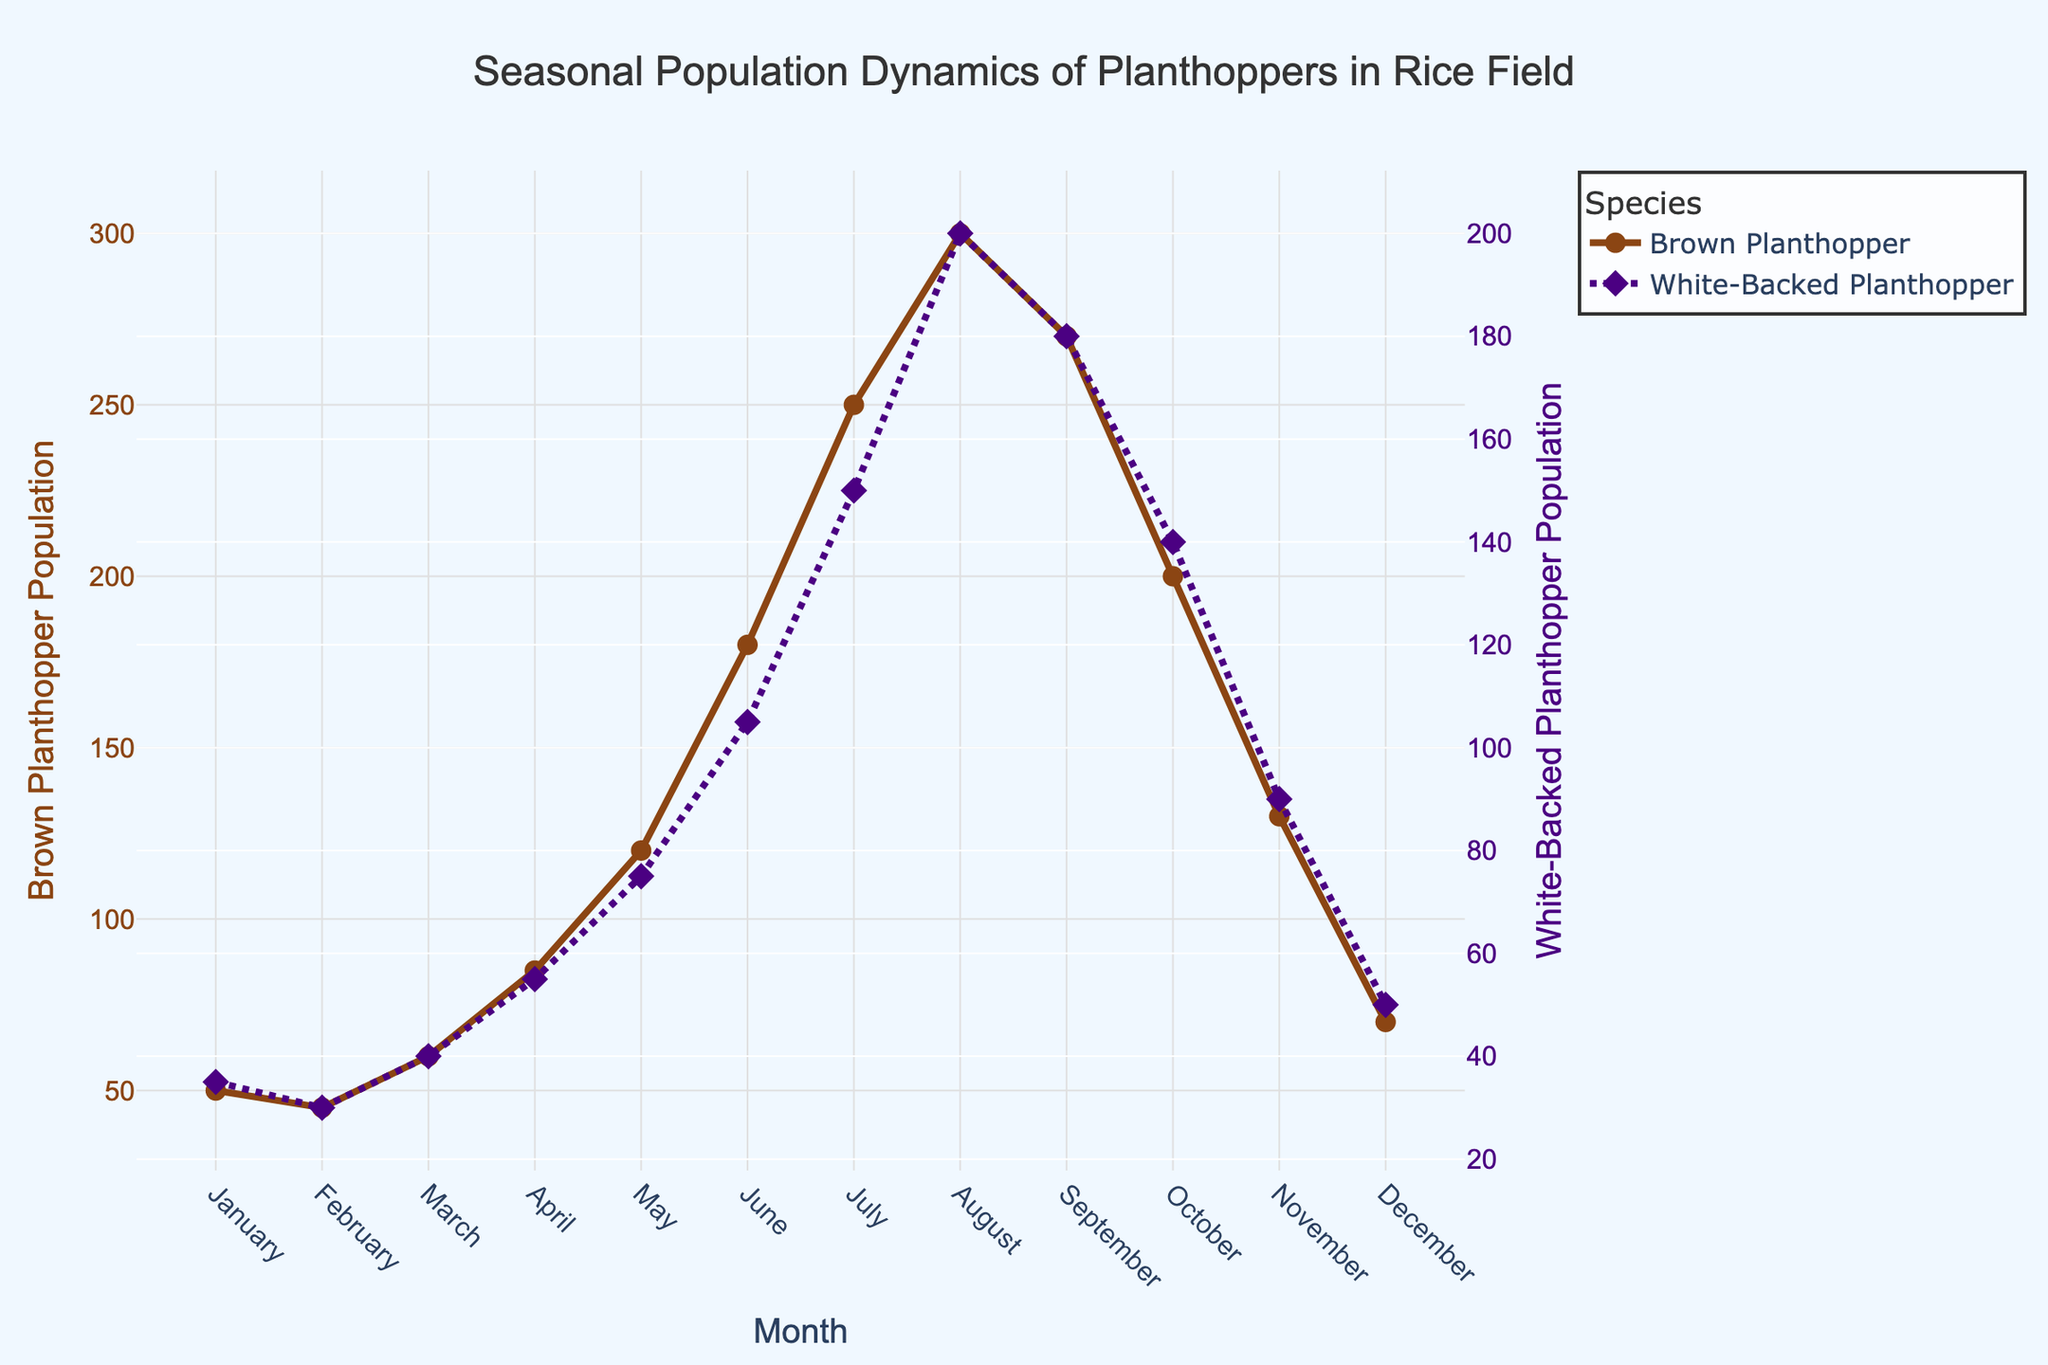what is the title of the plot? The title is usually located at the top of the plot and provides a summary of what the plot represents. Here, the title reads "Seasonal Population Dynamics of Planthoppers in Rice Field."
Answer: Seasonal Population Dynamics of Planthoppers in Rice Field which species of planthopper has symbols in the shape of circles on the plot? By examining the legend and the plotted lines, you can see that the line representing the Brown Planthopper has markers that are circular in shape.
Answer: Brown Planthopper in which month does the brown planthopper population peak? Observing the plot, you can see the peak point on the line representing the Brown Planthopper population. This peak occurs in August.
Answer: August compare the populations of both planthopper species in April. Which one is higher? Looking at the population values for April, the Brown Planthopper has a population of 85, whereas the White-Backed Planthopper has a population of 55. Therefore, the Brown Planthopper population is higher.
Answer: Brown Planthopper which months show a decline in brown planthopper population compared to the previous month? By following the trend line for the Brown Planthopper, you can observe declines from January to February, September to October, and October to November.
Answer: February, October, November what is the combined population of both planthopper species in June? The population of Brown Planthopper in June is 180 and the population of White-Backed Planthopper is 105. Adding these together gives 180 + 105 = 285.
Answer: 285 compare the month with the highest population for each planthopper species. The highest population for Brown Planthopper is in August (300) and for White-Backed Planthopper is also in August (200).
Answer: August what is the population difference between both species in July? In July, the population of Brown Planthopper is 250 and the population of White-Backed Planthopper is 150. The difference is 250 - 150 = 100.
Answer: 100 how does the population trend of the white-backed planthopper change from March to April? Looking at the trend from March to April for the White-Backed Planthopper, the population increases from 40 to 55.
Answer: Increases what is the average population of brown planthopper from January to June? Sum the populations from January to June (50+45+60+85+120+180 = 540) and divide by the number of months (6), which gives 540 / 6 = 90.
Answer: 90 